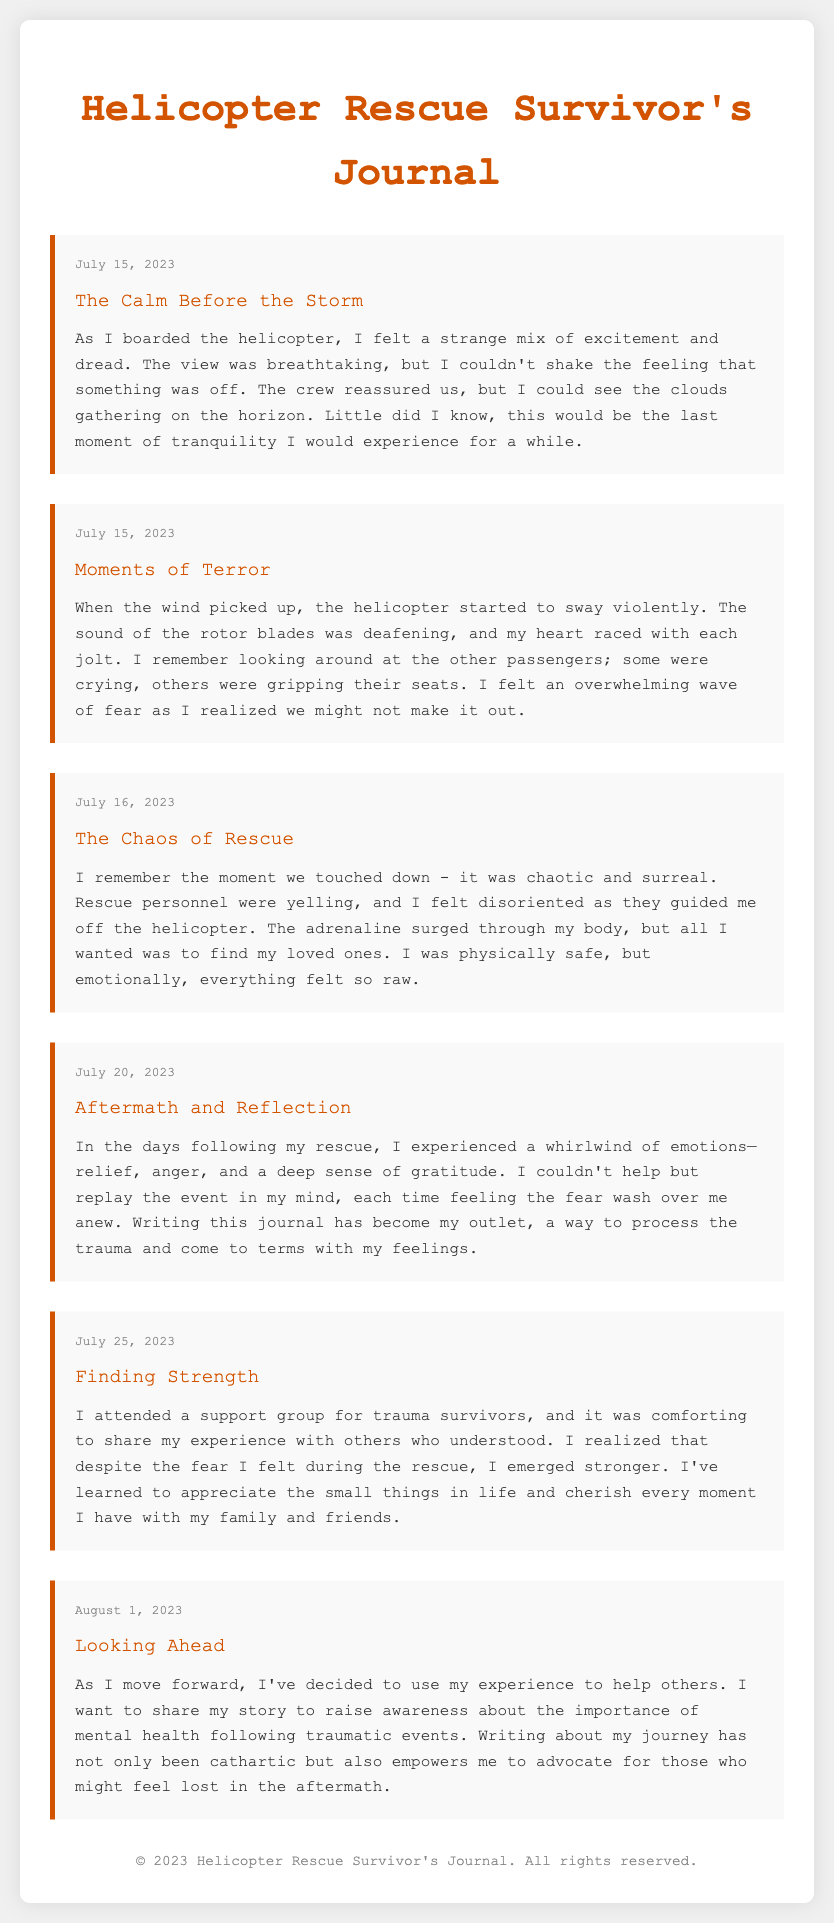What is the date of the first journal entry? The first journal entry is dated July 15, 2023, as indicated at the top of the entry.
Answer: July 15, 2023 What is the title of the third entry? The title of the third entry is found under the entry content and reads "The Chaos of Rescue."
Answer: The Chaos of Rescue How did the survivor feel during the initial flight? The emotions are detailed in the entry, indicating a mix of excitement and dread while boarding the helicopter.
Answer: Excitement and dread What event is described in the second journal entry? The second entry describes the intense events experienced during the helicopter ride, particularly the moments of terror.
Answer: Moments of Terror What type of support did the survivor seek post-rescue? The survivor attended a support group for trauma survivors, as mentioned in the journal entry about finding strength.
Answer: Support group What overarching theme can be identified in the survivor's reflections? The entries reflect a journey of processing trauma, emotional recovery, and personal empowerment after a traumatic incident.
Answer: Personal empowerment On what date did the survivor write about finding strength? The entry discussing finding strength specifically states the date it was written.
Answer: July 25, 2023 What emotion predominated the days following the rescue? The survivor experienced a mixture of emotions shortly after their rescue, highlighting one particular feeling.
Answer: Relief 